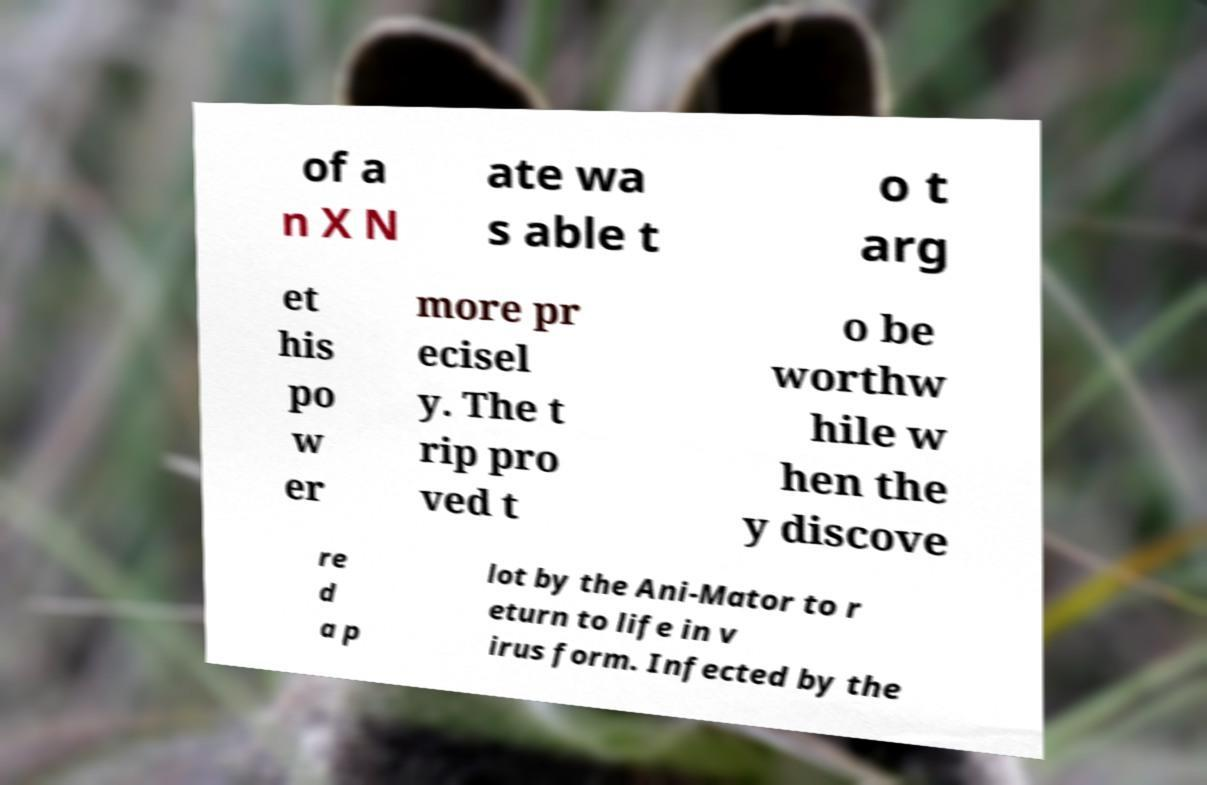For documentation purposes, I need the text within this image transcribed. Could you provide that? of a n X N ate wa s able t o t arg et his po w er more pr ecisel y. The t rip pro ved t o be worthw hile w hen the y discove re d a p lot by the Ani-Mator to r eturn to life in v irus form. Infected by the 